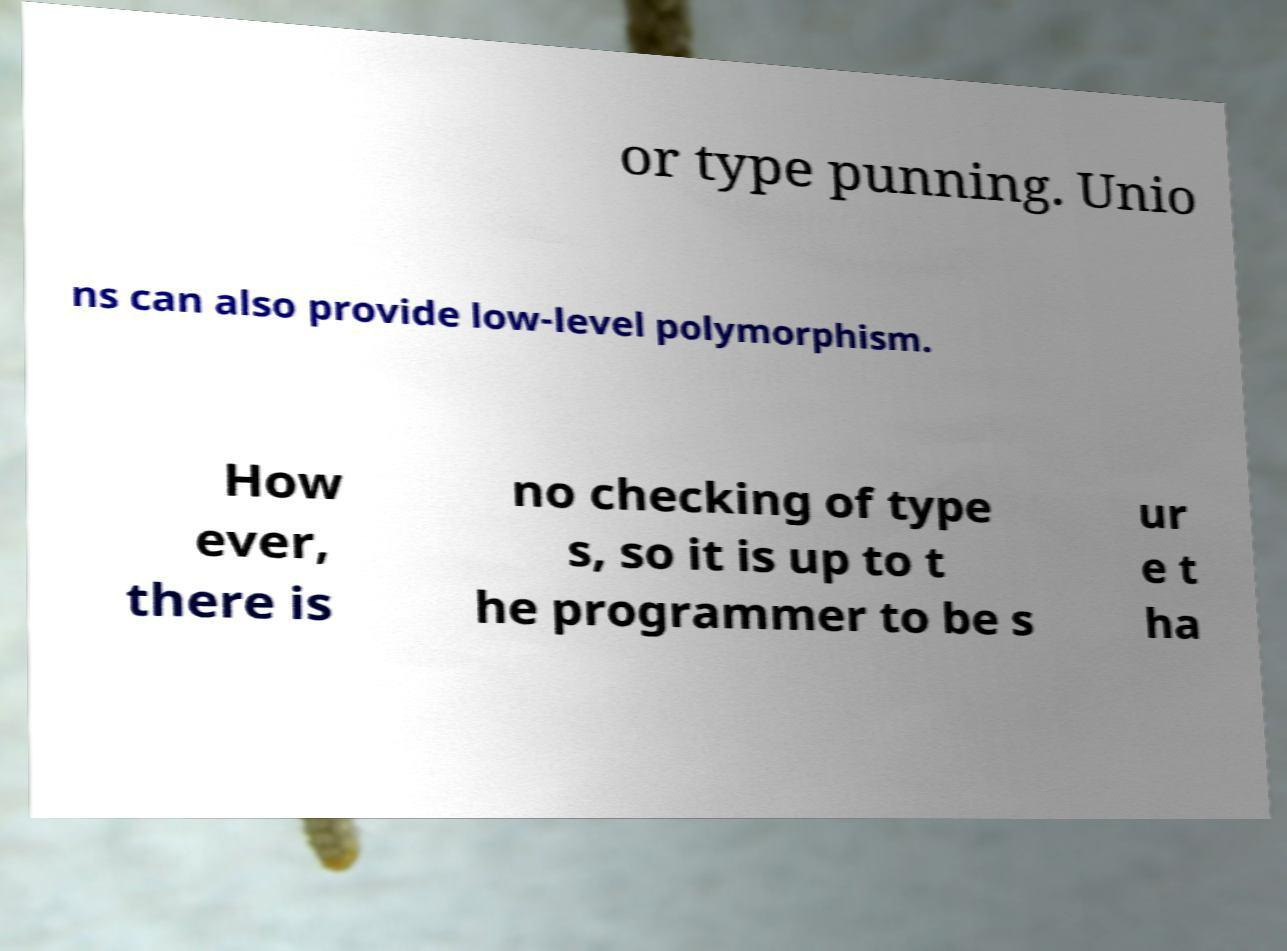Can you accurately transcribe the text from the provided image for me? or type punning. Unio ns can also provide low-level polymorphism. How ever, there is no checking of type s, so it is up to t he programmer to be s ur e t ha 